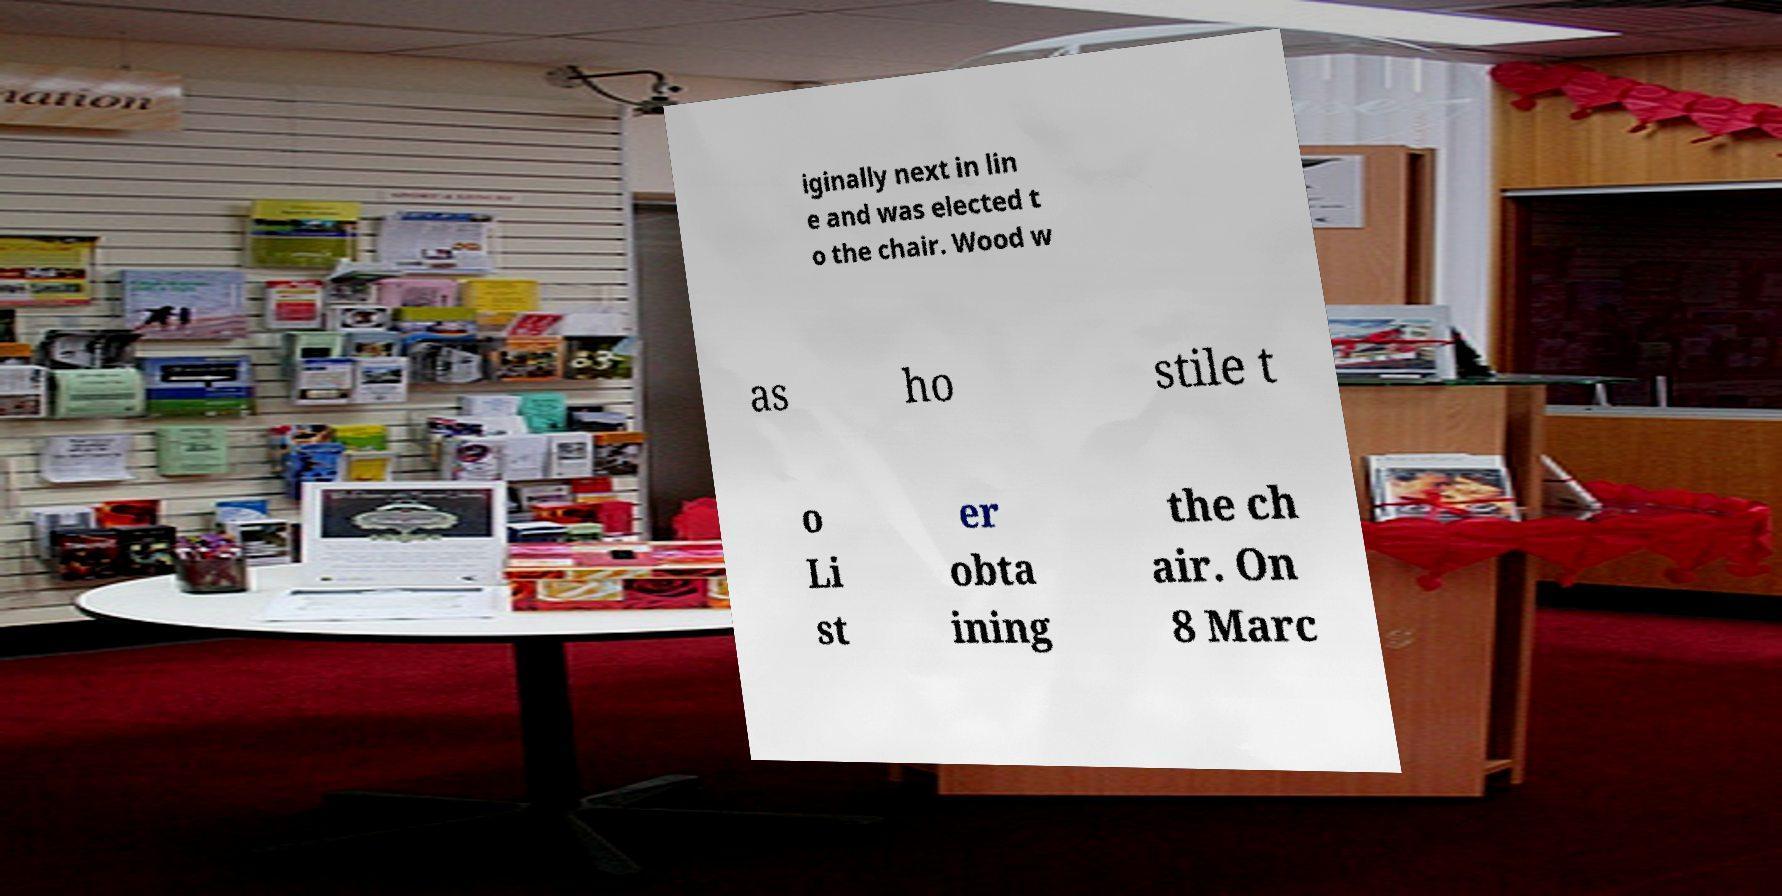Please identify and transcribe the text found in this image. iginally next in lin e and was elected t o the chair. Wood w as ho stile t o Li st er obta ining the ch air. On 8 Marc 